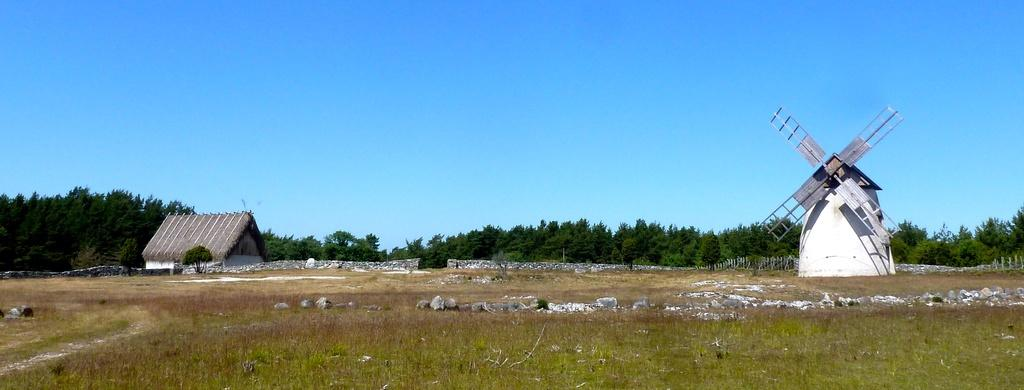What is the main structure visible in the image? There is a windmill in the image. What type of natural elements can be seen in the image? There are rocks, grass, and trees visible in the image. What type of building is present in the image? There is a house in the image. What is the color of the sky in the image? The sky is blue in the image. Can you see any toothpaste or soap in the image? There is no toothpaste or soap present in the image. Is there a stream visible in the image? There is no stream visible in the image. 